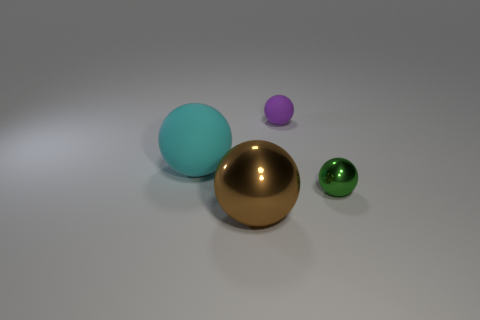There is a matte object to the right of the cyan rubber ball; is it the same size as the brown metallic ball?
Offer a very short reply. No. How many tiny metallic objects are to the left of the brown metallic sphere?
Offer a very short reply. 0. Are there fewer tiny green metal balls that are to the left of the brown shiny object than tiny objects that are on the right side of the purple rubber ball?
Provide a succinct answer. Yes. What number of balls are there?
Provide a short and direct response. 4. There is a rubber sphere that is left of the brown metal ball; what is its color?
Make the answer very short. Cyan. The cyan rubber thing has what size?
Provide a short and direct response. Large. There is a ball behind the big ball behind the brown ball; what color is it?
Your answer should be compact. Purple. How many things are in front of the small green thing and behind the big matte object?
Keep it short and to the point. 0. There is a tiny ball behind the sphere to the left of the big ball in front of the green metallic sphere; what color is it?
Provide a short and direct response. Purple. There is a sphere that is behind the cyan matte sphere; what number of large matte balls are in front of it?
Your answer should be very brief. 1. 